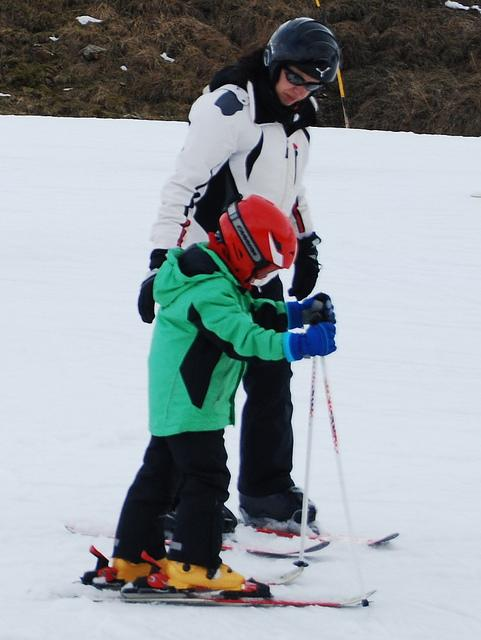Why are his skis so small? Please explain your reasoning. is child. An adult and a child are skiing. children wear smaller skis than adults. 